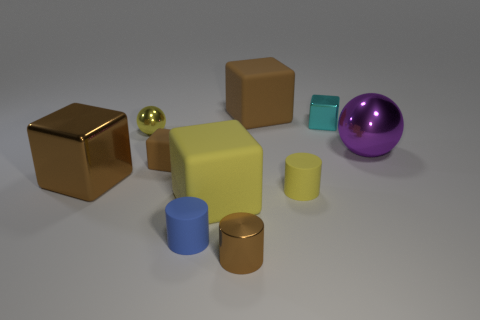Does the small cylinder behind the yellow block have the same color as the small metallic ball?
Ensure brevity in your answer.  Yes. How many small brown rubber objects are left of the small brown object behind the brown metal object that is in front of the yellow matte cylinder?
Make the answer very short. 0. There is a cyan thing; what number of tiny yellow balls are behind it?
Give a very brief answer. 0. The tiny shiny object that is the same shape as the large yellow thing is what color?
Provide a succinct answer. Cyan. There is a brown thing that is both in front of the tiny brown rubber object and right of the brown shiny block; what material is it?
Ensure brevity in your answer.  Metal. There is a rubber cylinder in front of the yellow matte cylinder; does it have the same size as the large purple metallic object?
Give a very brief answer. No. What is the material of the tiny cyan cube?
Provide a succinct answer. Metal. What is the color of the object on the right side of the tiny cyan cube?
Give a very brief answer. Purple. What number of tiny things are brown metal things or metallic spheres?
Make the answer very short. 2. Do the big rubber block in front of the large shiny block and the metal ball that is left of the large metal sphere have the same color?
Your answer should be very brief. Yes. 